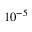Convert formula to latex. <formula><loc_0><loc_0><loc_500><loc_500>1 0 ^ { - 5 }</formula> 